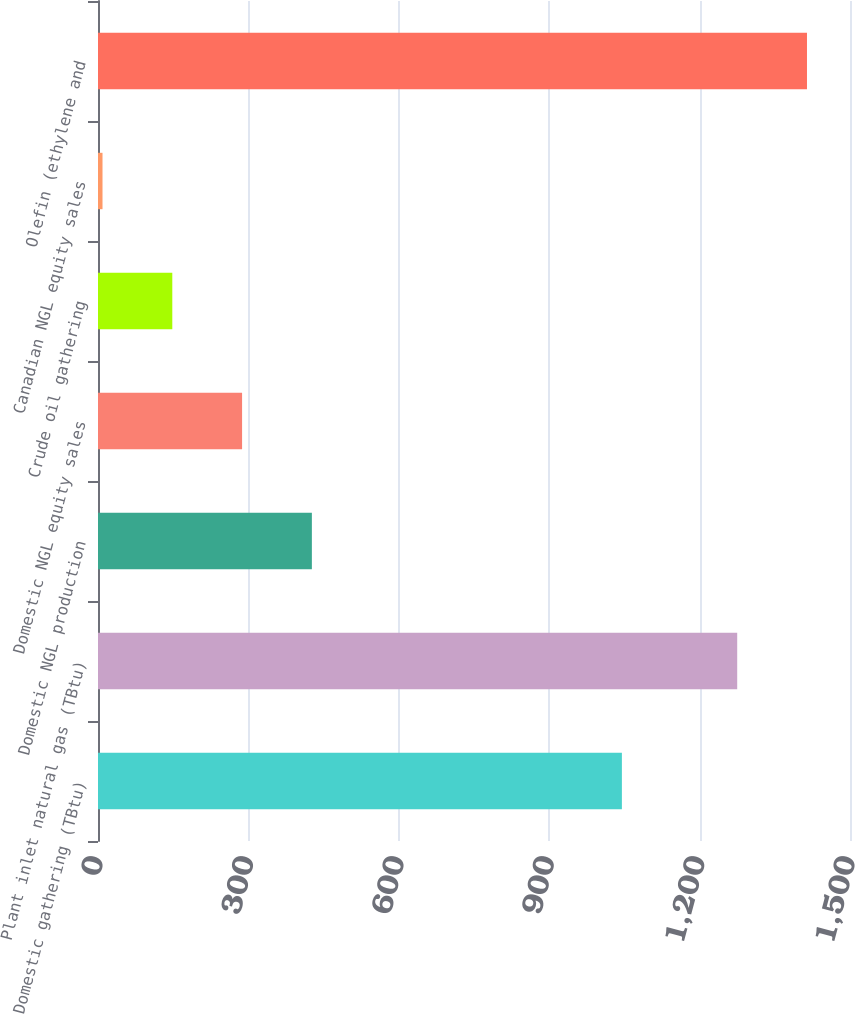Convert chart. <chart><loc_0><loc_0><loc_500><loc_500><bar_chart><fcel>Domestic gathering (TBtu)<fcel>Plant inlet natural gas (TBtu)<fcel>Domestic NGL production<fcel>Domestic NGL equity sales<fcel>Crude oil gathering<fcel>Canadian NGL equity sales<fcel>Olefin (ethylene and<nl><fcel>1045<fcel>1275<fcel>426.6<fcel>287.4<fcel>148.2<fcel>9<fcel>1414.2<nl></chart> 